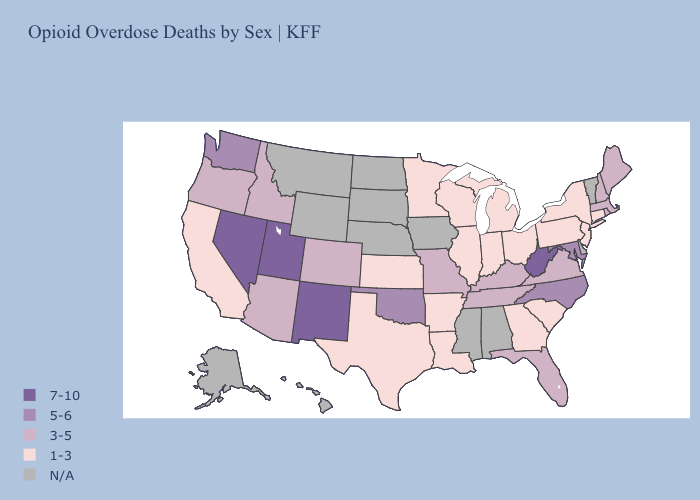Which states hav the highest value in the Northeast?
Keep it brief. Maine, Massachusetts, New Hampshire, Rhode Island. What is the highest value in states that border Rhode Island?
Give a very brief answer. 3-5. Name the states that have a value in the range 1-3?
Keep it brief. Arkansas, California, Connecticut, Georgia, Illinois, Indiana, Kansas, Louisiana, Michigan, Minnesota, New Jersey, New York, Ohio, Pennsylvania, South Carolina, Texas, Wisconsin. Which states have the lowest value in the West?
Quick response, please. California. Name the states that have a value in the range 5-6?
Answer briefly. Maryland, North Carolina, Oklahoma, Washington. What is the value of West Virginia?
Answer briefly. 7-10. Is the legend a continuous bar?
Be succinct. No. What is the lowest value in the USA?
Concise answer only. 1-3. Name the states that have a value in the range 7-10?
Concise answer only. Nevada, New Mexico, Utah, West Virginia. Name the states that have a value in the range 3-5?
Answer briefly. Arizona, Colorado, Florida, Idaho, Kentucky, Maine, Massachusetts, Missouri, New Hampshire, Oregon, Rhode Island, Tennessee, Virginia. Which states have the lowest value in the USA?
Answer briefly. Arkansas, California, Connecticut, Georgia, Illinois, Indiana, Kansas, Louisiana, Michigan, Minnesota, New Jersey, New York, Ohio, Pennsylvania, South Carolina, Texas, Wisconsin. Name the states that have a value in the range N/A?
Keep it brief. Alabama, Alaska, Delaware, Hawaii, Iowa, Mississippi, Montana, Nebraska, North Dakota, South Dakota, Vermont, Wyoming. What is the highest value in the USA?
Give a very brief answer. 7-10. What is the value of Alabama?
Concise answer only. N/A. 